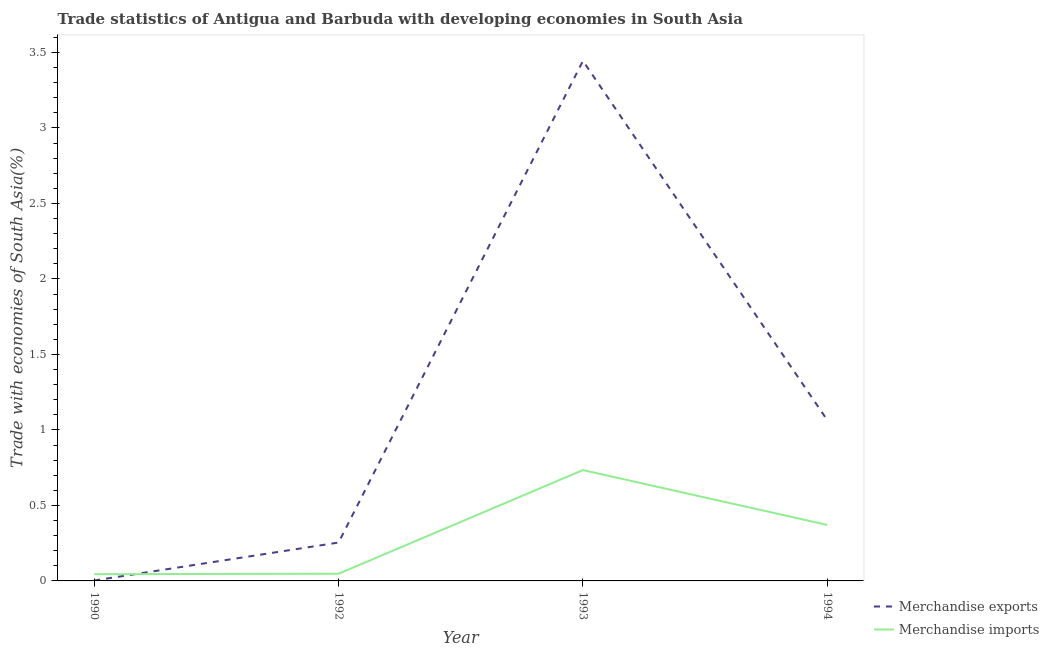How many different coloured lines are there?
Ensure brevity in your answer.  2. Does the line corresponding to merchandise imports intersect with the line corresponding to merchandise exports?
Provide a succinct answer. Yes. What is the merchandise imports in 1992?
Your answer should be compact. 0.05. Across all years, what is the maximum merchandise imports?
Keep it short and to the point. 0.73. Across all years, what is the minimum merchandise exports?
Give a very brief answer. 0. In which year was the merchandise exports minimum?
Offer a very short reply. 1990. What is the total merchandise imports in the graph?
Your response must be concise. 1.2. What is the difference between the merchandise exports in 1990 and that in 1994?
Make the answer very short. -1.06. What is the difference between the merchandise exports in 1994 and the merchandise imports in 1990?
Provide a short and direct response. 1.02. What is the average merchandise exports per year?
Keep it short and to the point. 1.19. In the year 1992, what is the difference between the merchandise exports and merchandise imports?
Keep it short and to the point. 0.21. In how many years, is the merchandise exports greater than 2.8 %?
Keep it short and to the point. 1. What is the ratio of the merchandise exports in 1993 to that in 1994?
Offer a very short reply. 3.24. Is the merchandise exports in 1990 less than that in 1994?
Your response must be concise. Yes. Is the difference between the merchandise imports in 1992 and 1994 greater than the difference between the merchandise exports in 1992 and 1994?
Your response must be concise. Yes. What is the difference between the highest and the second highest merchandise imports?
Give a very brief answer. 0.36. What is the difference between the highest and the lowest merchandise imports?
Your response must be concise. 0.69. Is the sum of the merchandise imports in 1992 and 1994 greater than the maximum merchandise exports across all years?
Your answer should be very brief. No. Is the merchandise exports strictly less than the merchandise imports over the years?
Ensure brevity in your answer.  No. How many years are there in the graph?
Provide a succinct answer. 4. Does the graph contain any zero values?
Give a very brief answer. No. Does the graph contain grids?
Make the answer very short. No. Where does the legend appear in the graph?
Provide a succinct answer. Bottom right. What is the title of the graph?
Ensure brevity in your answer.  Trade statistics of Antigua and Barbuda with developing economies in South Asia. What is the label or title of the X-axis?
Your response must be concise. Year. What is the label or title of the Y-axis?
Make the answer very short. Trade with economies of South Asia(%). What is the Trade with economies of South Asia(%) of Merchandise exports in 1990?
Keep it short and to the point. 0. What is the Trade with economies of South Asia(%) in Merchandise imports in 1990?
Give a very brief answer. 0.04. What is the Trade with economies of South Asia(%) in Merchandise exports in 1992?
Make the answer very short. 0.25. What is the Trade with economies of South Asia(%) of Merchandise imports in 1992?
Your answer should be very brief. 0.05. What is the Trade with economies of South Asia(%) of Merchandise exports in 1993?
Provide a short and direct response. 3.44. What is the Trade with economies of South Asia(%) of Merchandise imports in 1993?
Offer a very short reply. 0.73. What is the Trade with economies of South Asia(%) of Merchandise exports in 1994?
Make the answer very short. 1.06. What is the Trade with economies of South Asia(%) in Merchandise imports in 1994?
Your answer should be very brief. 0.37. Across all years, what is the maximum Trade with economies of South Asia(%) of Merchandise exports?
Your answer should be compact. 3.44. Across all years, what is the maximum Trade with economies of South Asia(%) of Merchandise imports?
Give a very brief answer. 0.73. Across all years, what is the minimum Trade with economies of South Asia(%) of Merchandise exports?
Keep it short and to the point. 0. Across all years, what is the minimum Trade with economies of South Asia(%) of Merchandise imports?
Your answer should be very brief. 0.04. What is the total Trade with economies of South Asia(%) of Merchandise exports in the graph?
Provide a succinct answer. 4.77. What is the total Trade with economies of South Asia(%) in Merchandise imports in the graph?
Ensure brevity in your answer.  1.2. What is the difference between the Trade with economies of South Asia(%) in Merchandise exports in 1990 and that in 1992?
Offer a terse response. -0.25. What is the difference between the Trade with economies of South Asia(%) of Merchandise imports in 1990 and that in 1992?
Offer a very short reply. -0. What is the difference between the Trade with economies of South Asia(%) in Merchandise exports in 1990 and that in 1993?
Offer a terse response. -3.44. What is the difference between the Trade with economies of South Asia(%) of Merchandise imports in 1990 and that in 1993?
Provide a succinct answer. -0.69. What is the difference between the Trade with economies of South Asia(%) of Merchandise exports in 1990 and that in 1994?
Provide a succinct answer. -1.06. What is the difference between the Trade with economies of South Asia(%) in Merchandise imports in 1990 and that in 1994?
Your answer should be compact. -0.33. What is the difference between the Trade with economies of South Asia(%) of Merchandise exports in 1992 and that in 1993?
Give a very brief answer. -3.19. What is the difference between the Trade with economies of South Asia(%) in Merchandise imports in 1992 and that in 1993?
Offer a terse response. -0.69. What is the difference between the Trade with economies of South Asia(%) in Merchandise exports in 1992 and that in 1994?
Offer a terse response. -0.81. What is the difference between the Trade with economies of South Asia(%) in Merchandise imports in 1992 and that in 1994?
Ensure brevity in your answer.  -0.32. What is the difference between the Trade with economies of South Asia(%) in Merchandise exports in 1993 and that in 1994?
Provide a succinct answer. 2.38. What is the difference between the Trade with economies of South Asia(%) of Merchandise imports in 1993 and that in 1994?
Ensure brevity in your answer.  0.36. What is the difference between the Trade with economies of South Asia(%) in Merchandise exports in 1990 and the Trade with economies of South Asia(%) in Merchandise imports in 1992?
Ensure brevity in your answer.  -0.04. What is the difference between the Trade with economies of South Asia(%) of Merchandise exports in 1990 and the Trade with economies of South Asia(%) of Merchandise imports in 1993?
Offer a terse response. -0.73. What is the difference between the Trade with economies of South Asia(%) in Merchandise exports in 1990 and the Trade with economies of South Asia(%) in Merchandise imports in 1994?
Offer a terse response. -0.37. What is the difference between the Trade with economies of South Asia(%) of Merchandise exports in 1992 and the Trade with economies of South Asia(%) of Merchandise imports in 1993?
Keep it short and to the point. -0.48. What is the difference between the Trade with economies of South Asia(%) in Merchandise exports in 1992 and the Trade with economies of South Asia(%) in Merchandise imports in 1994?
Make the answer very short. -0.12. What is the difference between the Trade with economies of South Asia(%) of Merchandise exports in 1993 and the Trade with economies of South Asia(%) of Merchandise imports in 1994?
Ensure brevity in your answer.  3.07. What is the average Trade with economies of South Asia(%) in Merchandise exports per year?
Your response must be concise. 1.19. What is the average Trade with economies of South Asia(%) of Merchandise imports per year?
Your answer should be very brief. 0.3. In the year 1990, what is the difference between the Trade with economies of South Asia(%) of Merchandise exports and Trade with economies of South Asia(%) of Merchandise imports?
Your response must be concise. -0.04. In the year 1992, what is the difference between the Trade with economies of South Asia(%) in Merchandise exports and Trade with economies of South Asia(%) in Merchandise imports?
Ensure brevity in your answer.  0.21. In the year 1993, what is the difference between the Trade with economies of South Asia(%) in Merchandise exports and Trade with economies of South Asia(%) in Merchandise imports?
Your response must be concise. 2.71. In the year 1994, what is the difference between the Trade with economies of South Asia(%) in Merchandise exports and Trade with economies of South Asia(%) in Merchandise imports?
Provide a succinct answer. 0.69. What is the ratio of the Trade with economies of South Asia(%) of Merchandise exports in 1990 to that in 1992?
Offer a very short reply. 0.01. What is the ratio of the Trade with economies of South Asia(%) in Merchandise imports in 1990 to that in 1992?
Make the answer very short. 0.94. What is the ratio of the Trade with economies of South Asia(%) of Merchandise exports in 1990 to that in 1993?
Make the answer very short. 0. What is the ratio of the Trade with economies of South Asia(%) in Merchandise imports in 1990 to that in 1993?
Ensure brevity in your answer.  0.06. What is the ratio of the Trade with economies of South Asia(%) in Merchandise exports in 1990 to that in 1994?
Keep it short and to the point. 0. What is the ratio of the Trade with economies of South Asia(%) of Merchandise imports in 1990 to that in 1994?
Provide a short and direct response. 0.12. What is the ratio of the Trade with economies of South Asia(%) in Merchandise exports in 1992 to that in 1993?
Keep it short and to the point. 0.07. What is the ratio of the Trade with economies of South Asia(%) in Merchandise imports in 1992 to that in 1993?
Ensure brevity in your answer.  0.06. What is the ratio of the Trade with economies of South Asia(%) of Merchandise exports in 1992 to that in 1994?
Keep it short and to the point. 0.24. What is the ratio of the Trade with economies of South Asia(%) of Merchandise imports in 1992 to that in 1994?
Give a very brief answer. 0.13. What is the ratio of the Trade with economies of South Asia(%) of Merchandise exports in 1993 to that in 1994?
Make the answer very short. 3.24. What is the ratio of the Trade with economies of South Asia(%) of Merchandise imports in 1993 to that in 1994?
Keep it short and to the point. 1.98. What is the difference between the highest and the second highest Trade with economies of South Asia(%) in Merchandise exports?
Provide a succinct answer. 2.38. What is the difference between the highest and the second highest Trade with economies of South Asia(%) of Merchandise imports?
Your response must be concise. 0.36. What is the difference between the highest and the lowest Trade with economies of South Asia(%) of Merchandise exports?
Keep it short and to the point. 3.44. What is the difference between the highest and the lowest Trade with economies of South Asia(%) in Merchandise imports?
Ensure brevity in your answer.  0.69. 